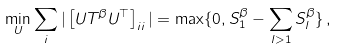<formula> <loc_0><loc_0><loc_500><loc_500>\min _ { U } \sum _ { i } | \left [ U T ^ { \beta } U ^ { \top } \right ] _ { i i } | = \max \{ 0 , S _ { 1 } ^ { \beta } - \sum _ { l > 1 } S _ { l } ^ { \beta } \} \, ,</formula> 